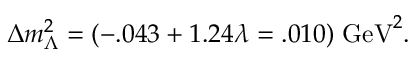<formula> <loc_0><loc_0><loc_500><loc_500>\Delta m _ { \Lambda } ^ { 2 } = ( - . 0 4 3 + 1 . 2 4 \lambda = . 0 1 0 ) \, G e V ^ { 2 } .</formula> 